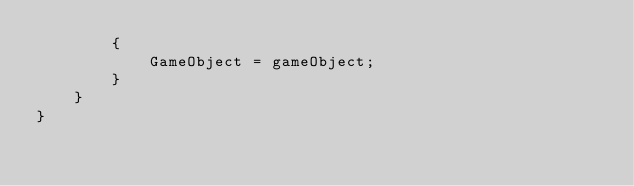<code> <loc_0><loc_0><loc_500><loc_500><_C#_>        {
            GameObject = gameObject;
        }
    }
}</code> 